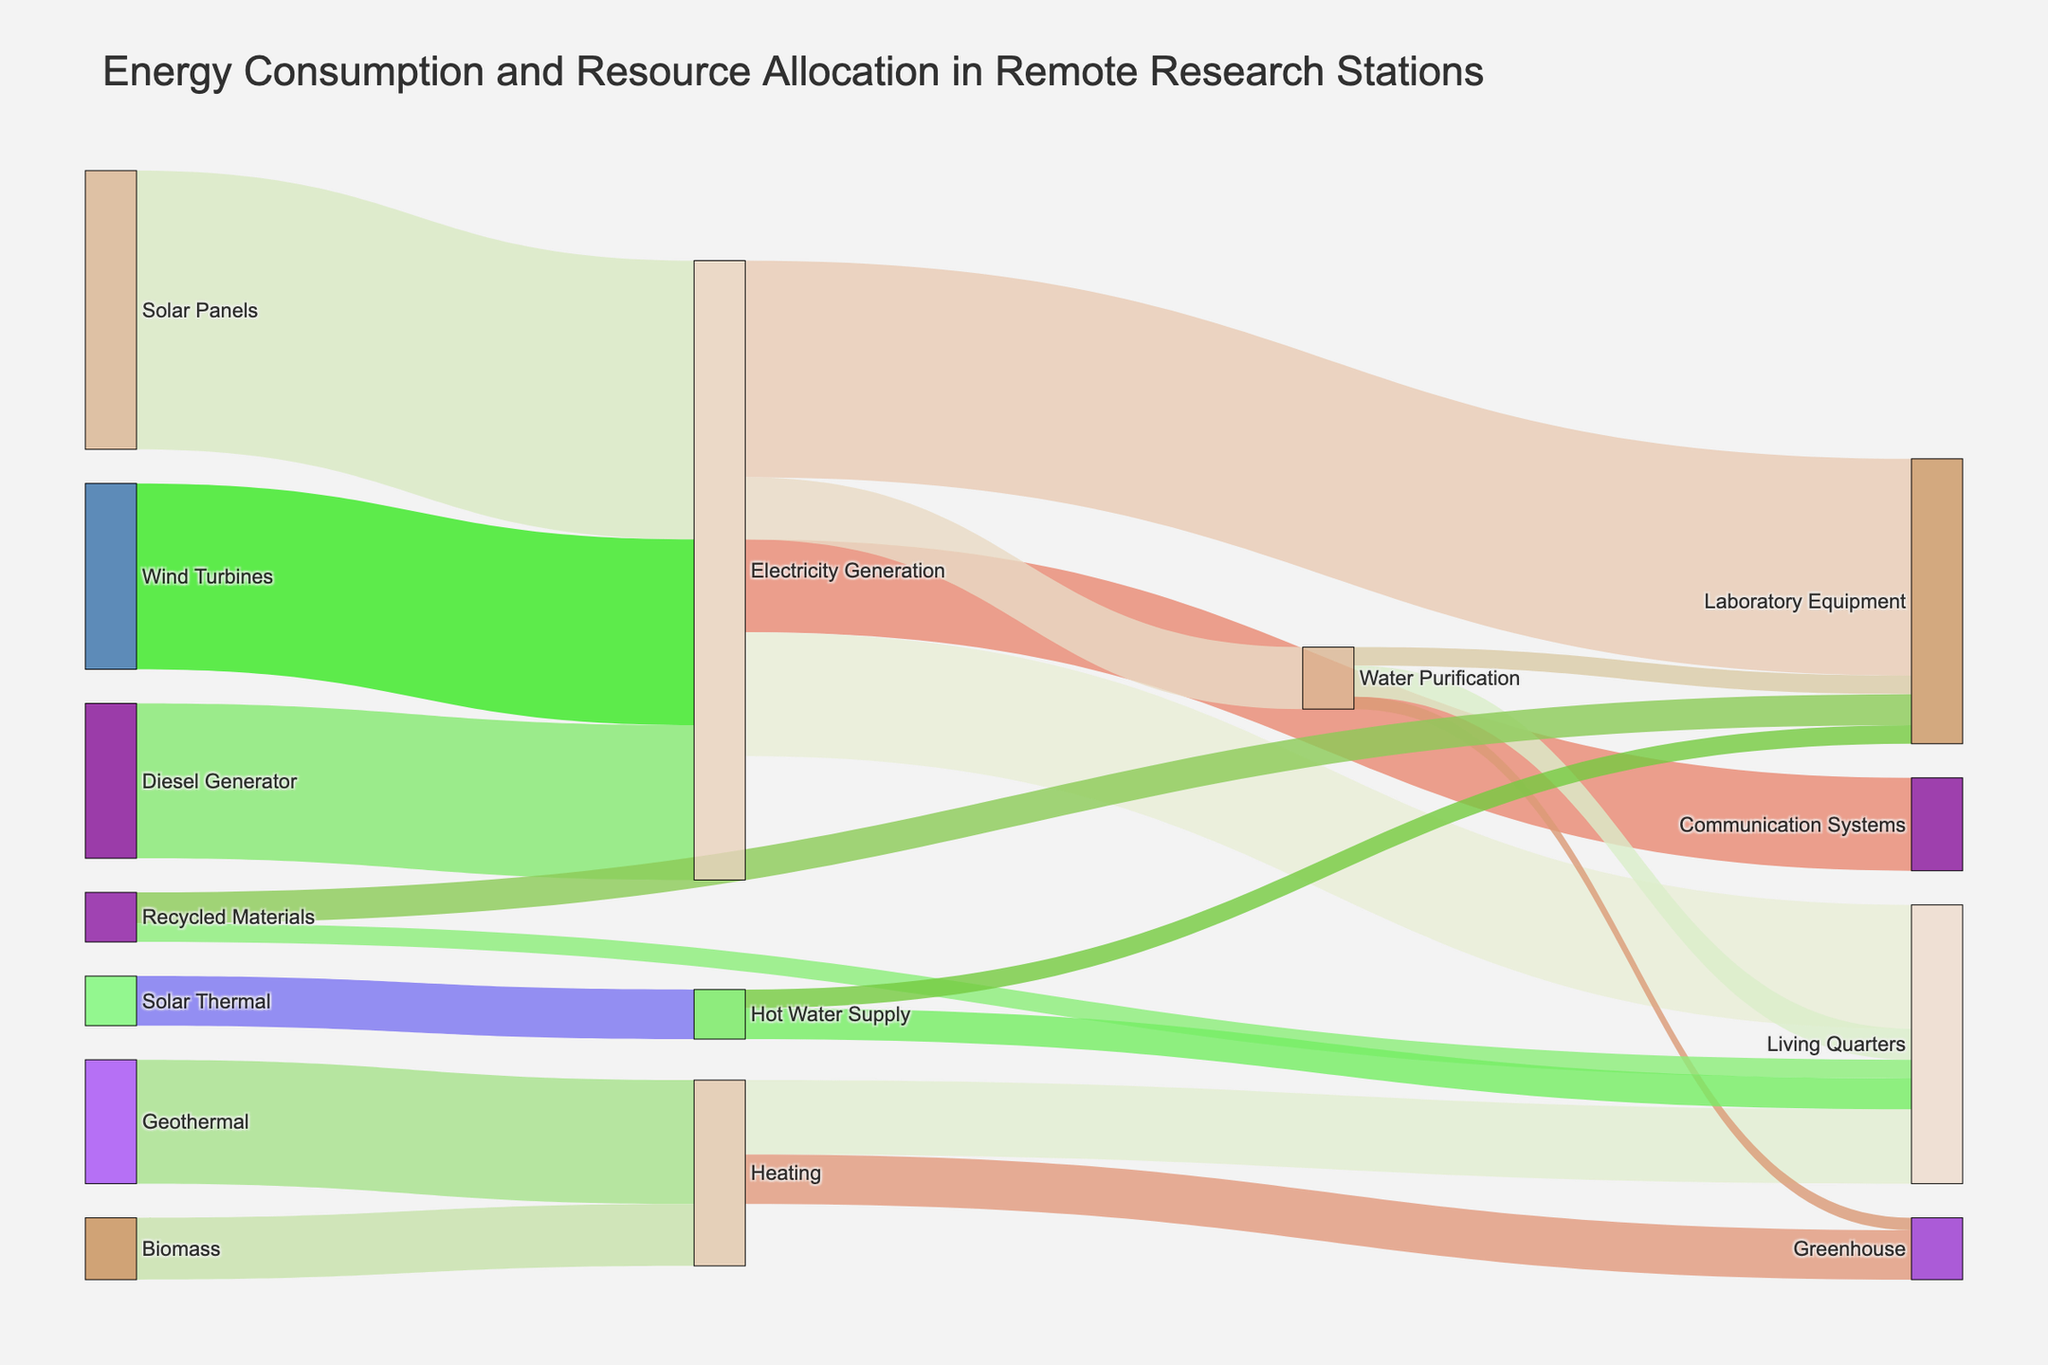What is the main source of electricity generation in the research station? By checking the width of the flows leading into the "Electricity Generation" node, it's clear that Solar Panels contribute the most with 450 units.
Answer: Solar Panels How much energy is used by Laboratory Equipment in total? By adding the values of the flows leading into "Laboratory Equipment" from different sources: 350 from Electricity Generation, 30 from Water Purification, and 50 from Recycled Materials, the total is 350 + 30 + 50 = 430 units.
Answer: 430 units Which source provides the least energy to Heating? Comparing the contributions to the "Heating" node, Biomass contributes 100 units while Geothermal provides 200 units. Thus, Biomass provides the least energy.
Answer: Biomass How much energy is allocated to Living Quarters from all sources combined? Summing the values that lead to "Living Quarters" from different sources: 200 from Electricity Generation, 120 from Heating, 50 from Water Purification, and 50 from Hot Water Supply, the total is 200 + 120 + 50 + 50 = 420 units.
Answer: 420 units Which category uses more energy: Communication Systems or Greenhouse? Comparing the flows, Communication Systems use 150 units directly from Electricity Generation, while the Greenhouse uses 80 units from Heating plus 20 units from Water Purification, totaling 100 units. So, Communication Systems use more energy.
Answer: Communication Systems What percentage of the energy generated by Wind Turbines is used for Laboratory Equipment? The total energy generated by Wind Turbines is 300 units. Out of this, 350 units go to Laboratory Equipment (which also includes energy from other sources). To find the specific percentage for Wind Turbines, it's necessary to note that all the energy from Wind Turbines goes through Electricity Generation, but calculations for specific contributions would require detailed disaggregation.
Answer: Calculation needed from detailed data Is more energy derived from Solar Panels or Diesel Generator in the research station? Comparing the totals, Solar Panels provide 450 units, while Diesel Generator provides 250 units. Hence, more energy is derived from Solar Panels.
Answer: Solar Panels What is the sum of all energy produced by renewable sources? Renewable sources include Solar Panels (450), Wind Turbines (300), Geothermal (200), Biomass (100), and Solar Thermal (80). Summing these values, 450 + 300 + 200 + 100 + 80 = 1130 units.
Answer: 1130 units Which single usage consumes the highest amount of energy directly from Electricity Generation? The flows from Electricity Generation show Laboratory Equipment receiving the highest amount with 350 units.
Answer: Laboratory Equipment 